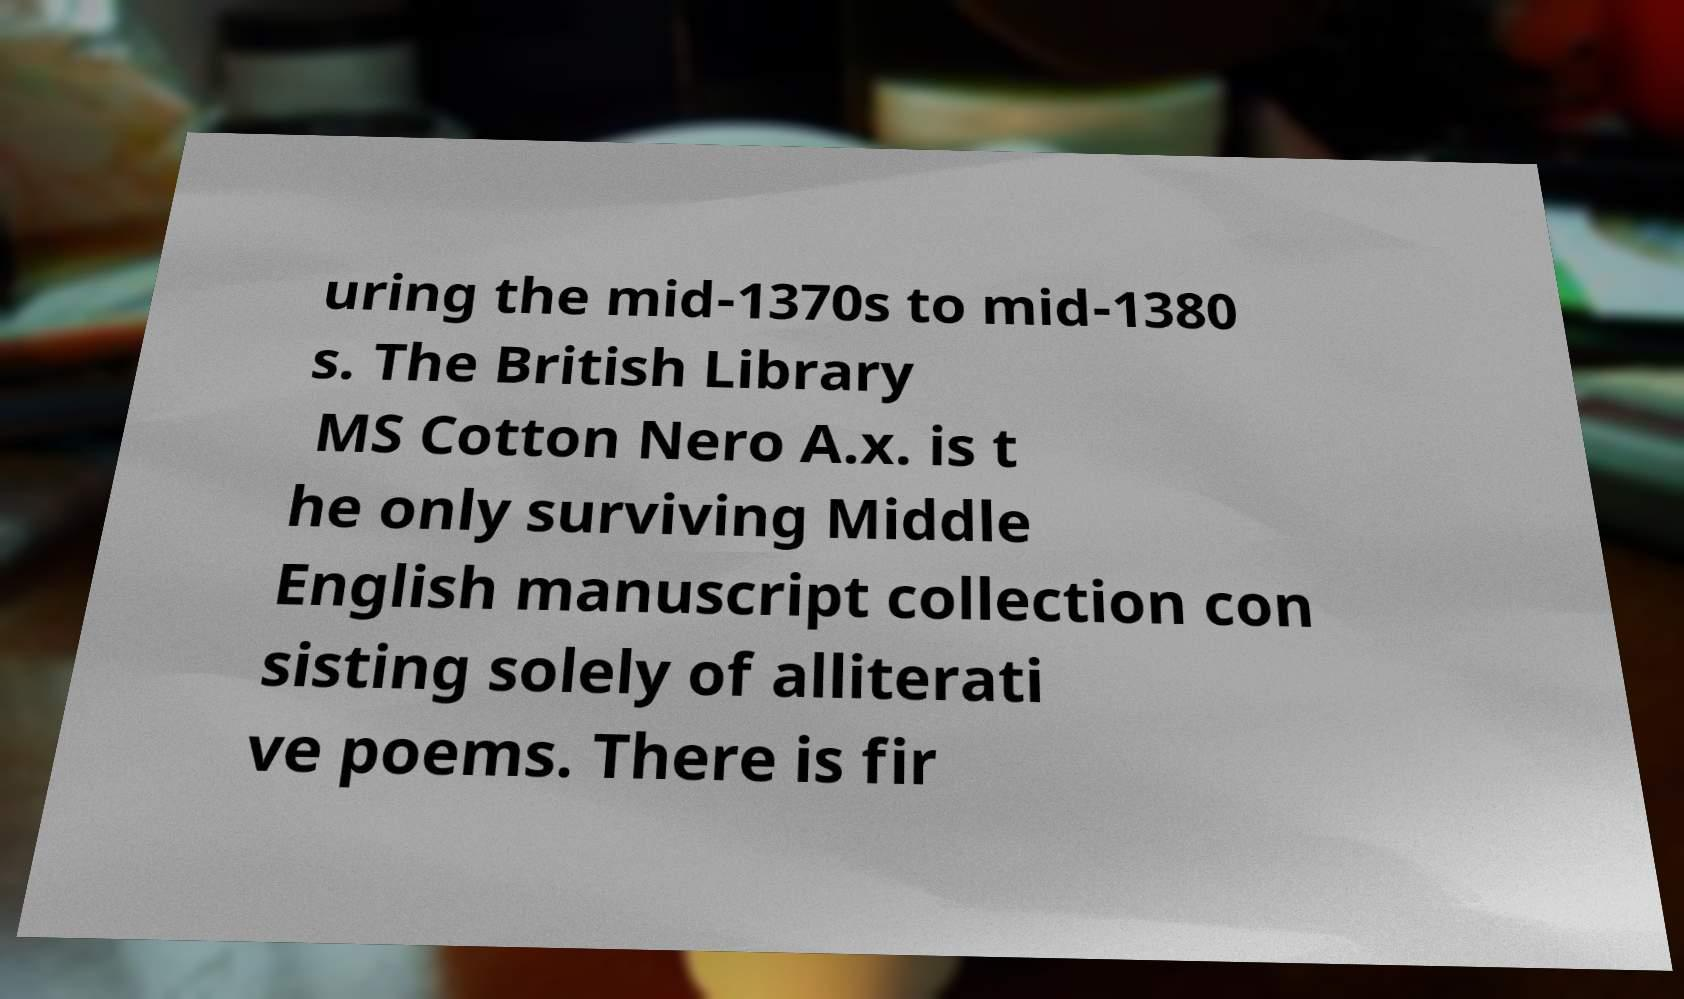For documentation purposes, I need the text within this image transcribed. Could you provide that? uring the mid-1370s to mid-1380 s. The British Library MS Cotton Nero A.x. is t he only surviving Middle English manuscript collection con sisting solely of alliterati ve poems. There is fir 